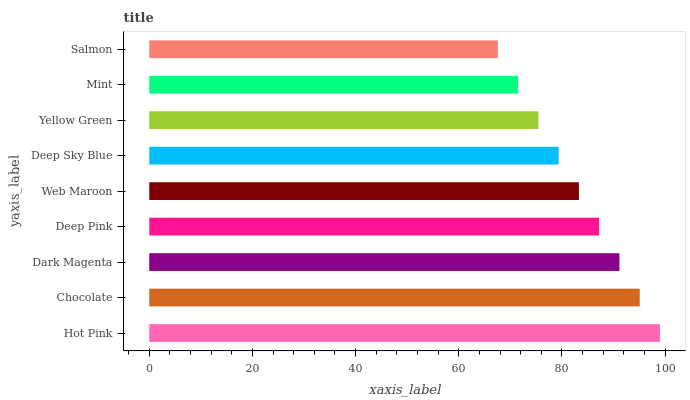Is Salmon the minimum?
Answer yes or no. Yes. Is Hot Pink the maximum?
Answer yes or no. Yes. Is Chocolate the minimum?
Answer yes or no. No. Is Chocolate the maximum?
Answer yes or no. No. Is Hot Pink greater than Chocolate?
Answer yes or no. Yes. Is Chocolate less than Hot Pink?
Answer yes or no. Yes. Is Chocolate greater than Hot Pink?
Answer yes or no. No. Is Hot Pink less than Chocolate?
Answer yes or no. No. Is Web Maroon the high median?
Answer yes or no. Yes. Is Web Maroon the low median?
Answer yes or no. Yes. Is Mint the high median?
Answer yes or no. No. Is Chocolate the low median?
Answer yes or no. No. 